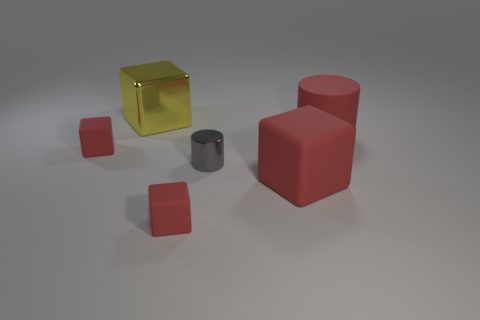How many big objects are both behind the tiny gray metallic thing and on the right side of the shiny block?
Provide a succinct answer. 1. Is the number of yellow metallic cubes in front of the large yellow cube the same as the number of red objects to the right of the large matte cube?
Offer a terse response. No. There is a thing on the left side of the yellow metallic thing; is its size the same as the gray metallic cylinder that is in front of the yellow cube?
Your response must be concise. Yes. There is a red thing that is both in front of the matte cylinder and to the right of the shiny cylinder; what material is it made of?
Your answer should be very brief. Rubber. Is the number of cylinders less than the number of large yellow matte things?
Offer a very short reply. No. There is a gray cylinder in front of the red thing on the left side of the yellow metallic cube; how big is it?
Give a very brief answer. Small. What is the shape of the red rubber object that is to the left of the big cube that is left of the large red rubber cube in front of the big yellow block?
Your answer should be compact. Cube. There is a large cube that is the same material as the large cylinder; what color is it?
Your response must be concise. Red. The matte object that is on the left side of the big thing on the left side of the small object that is in front of the tiny gray shiny cylinder is what color?
Give a very brief answer. Red. How many spheres are red matte objects or tiny metallic things?
Provide a short and direct response. 0. 